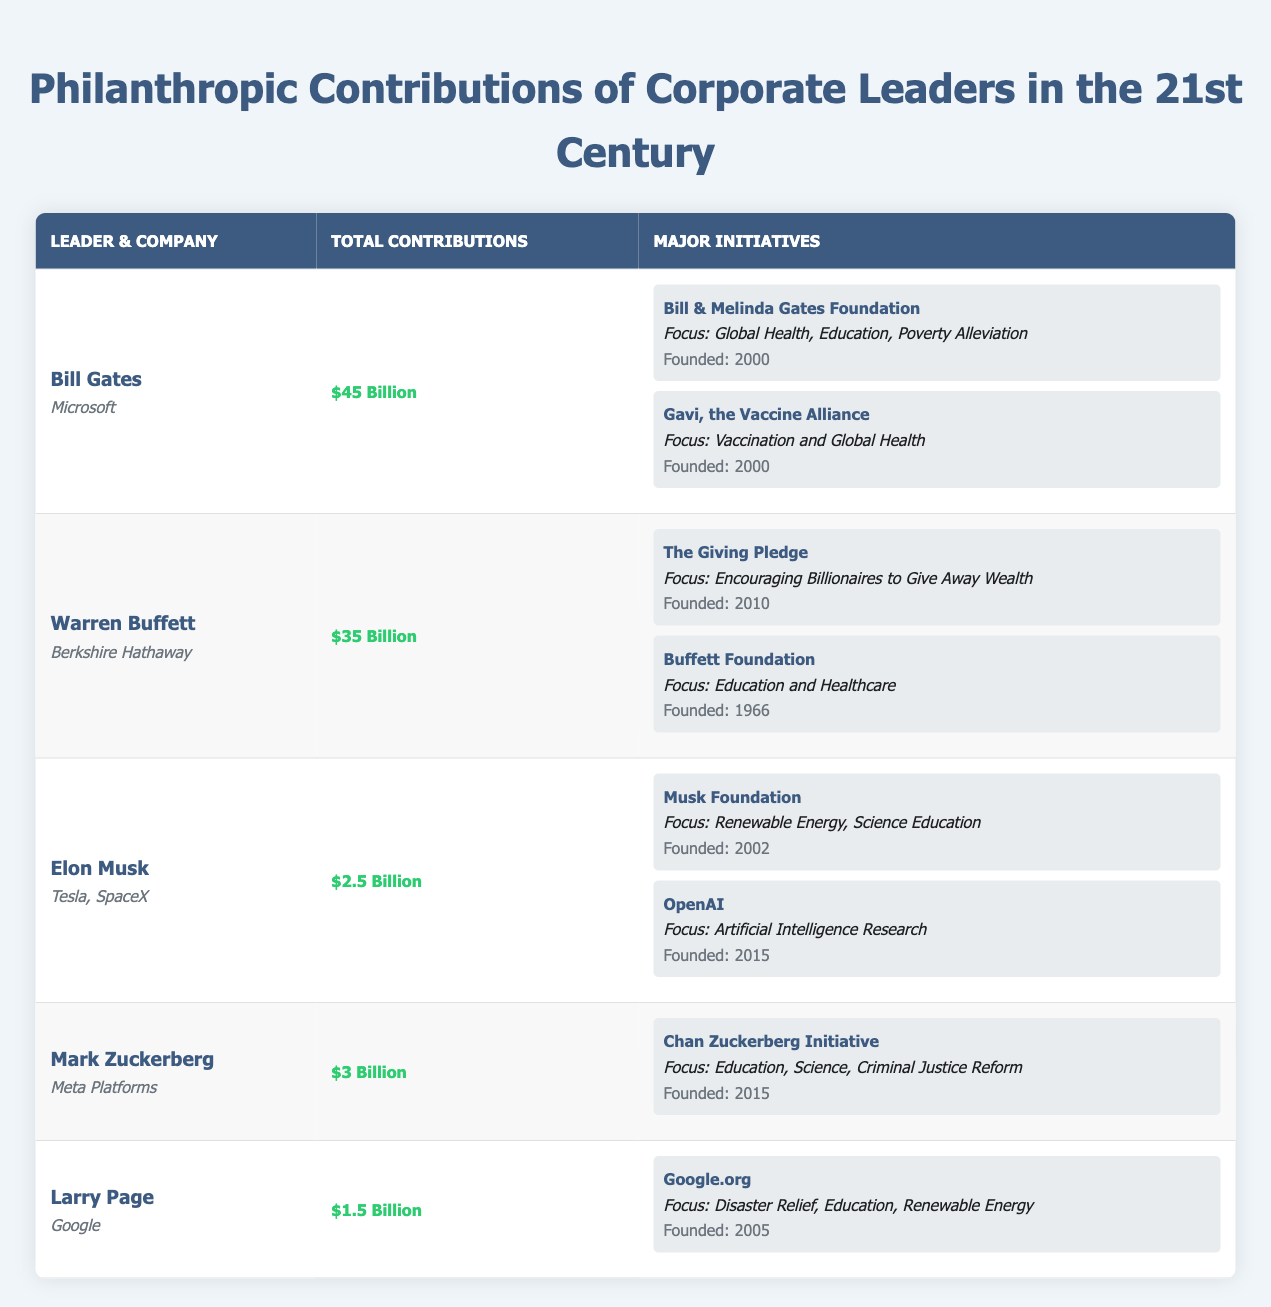What is the total philanthropic contribution of Bill Gates? From the table, Bill Gates has a total contribution of $45 Billion.
Answer: $45 Billion Which corporate leader founded the Chan Zuckerberg Initiative? The table shows that Mark Zuckerberg is the corporate leader who founded the Chan Zuckerberg Initiative.
Answer: Mark Zuckerberg What are the focus areas of Warren Buffett's philanthropic initiatives? The table lists the initiatives from Warren Buffett, with focus areas including encouraging billionaires to give away wealth, education, and healthcare.
Answer: Encouraging billionaires to give away wealth, education, and healthcare Which corporate leader has the least total contributions and how much? By comparing the values in the "Total Contributions" column, Larry Page has the least total contributions at $1.5 Billion.
Answer: $1.5 Billion True or False: Elon Musk's total contributions are equal to the sum of Larry Page's and Mark Zuckerberg's contributions. The total contributions for Larry Page and Mark Zuckerberg are $1.5 Billion + $3 Billion = $4.5 Billion. Elon Musk's contributions are $2.5 Billion, which is not equal. Therefore, the statement is False.
Answer: False What is the difference in total contributions between Bill Gates and Warren Buffett? The total contributions are $45 Billion for Bill Gates and $35 Billion for Warren Buffett. The difference is calculated as $45 Billion - $35 Billion = $10 Billion.
Answer: $10 Billion How many initiatives has Elon Musk founded? The table indicates that Elon Musk has founded two initiatives, namely the Musk Foundation and OpenAI.
Answer: 2 Which focus area is common between two different initiatives founded by Bill Gates? Both initiatives founded by Bill Gates, the Bill & Melinda Gates Foundation and Gavi, the Vaccine Alliance, share a common focus area on global health.
Answer: Global Health What year was the Giving Pledge founded? The table indicates that the Giving Pledge was founded in 2010.
Answer: 2010 